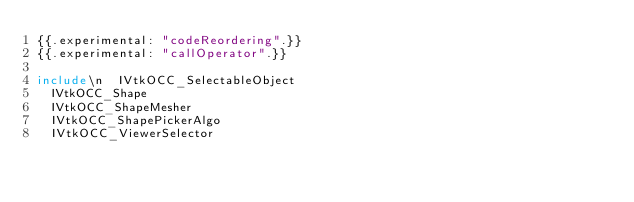<code> <loc_0><loc_0><loc_500><loc_500><_Nim_>{{.experimental: "codeReordering".}}
{{.experimental: "callOperator".}}

include\n  IVtkOCC_SelectableObject
  IVtkOCC_Shape
  IVtkOCC_ShapeMesher
  IVtkOCC_ShapePickerAlgo
  IVtkOCC_ViewerSelector




















































</code> 